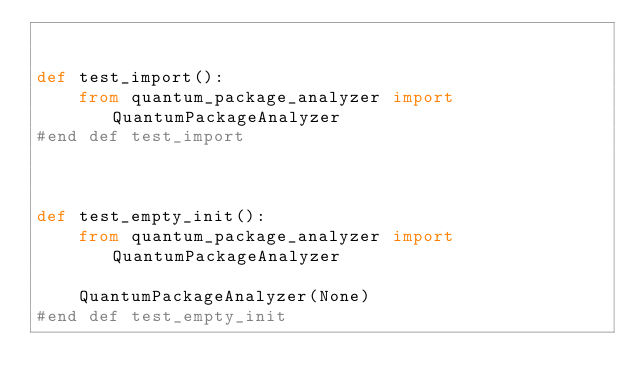Convert code to text. <code><loc_0><loc_0><loc_500><loc_500><_Python_>

def test_import():
    from quantum_package_analyzer import QuantumPackageAnalyzer
#end def test_import



def test_empty_init():
    from quantum_package_analyzer import QuantumPackageAnalyzer

    QuantumPackageAnalyzer(None)
#end def test_empty_init
</code> 